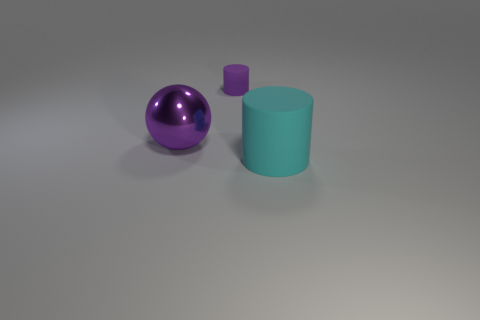Do the rubber cylinder that is behind the ball and the large rubber thing have the same size?
Make the answer very short. No. Does the purple thing that is left of the small purple cylinder have the same material as the large thing that is on the right side of the big purple ball?
Your answer should be very brief. No. Are there any balls of the same size as the cyan matte cylinder?
Offer a terse response. Yes. What is the shape of the rubber thing that is behind the matte cylinder right of the cylinder behind the large purple thing?
Give a very brief answer. Cylinder. Are there more small rubber things in front of the big purple metal ball than cyan cylinders?
Offer a very short reply. No. Are there any big metal things that have the same shape as the tiny rubber thing?
Make the answer very short. No. Is the cyan cylinder made of the same material as the purple thing that is in front of the small rubber thing?
Provide a short and direct response. No. The small object is what color?
Your response must be concise. Purple. There is a large object that is on the left side of the large thing that is in front of the shiny ball; how many big objects are on the right side of it?
Keep it short and to the point. 1. Are there any large purple things behind the tiny purple rubber cylinder?
Your answer should be compact. No. 